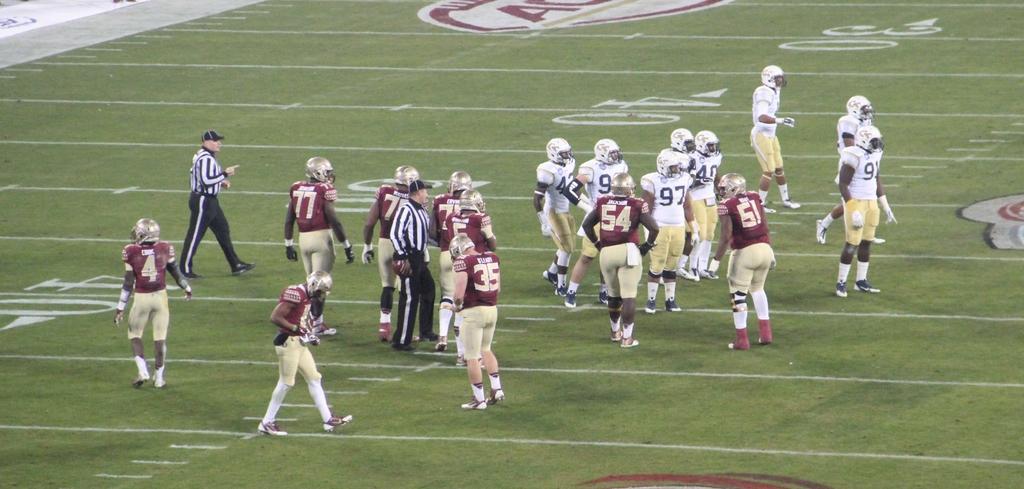In one or two sentences, can you explain what this image depicts? In this image, I can see the groups of people standing. They wore helmets and kick american football players costumes. This looks like a ground. 